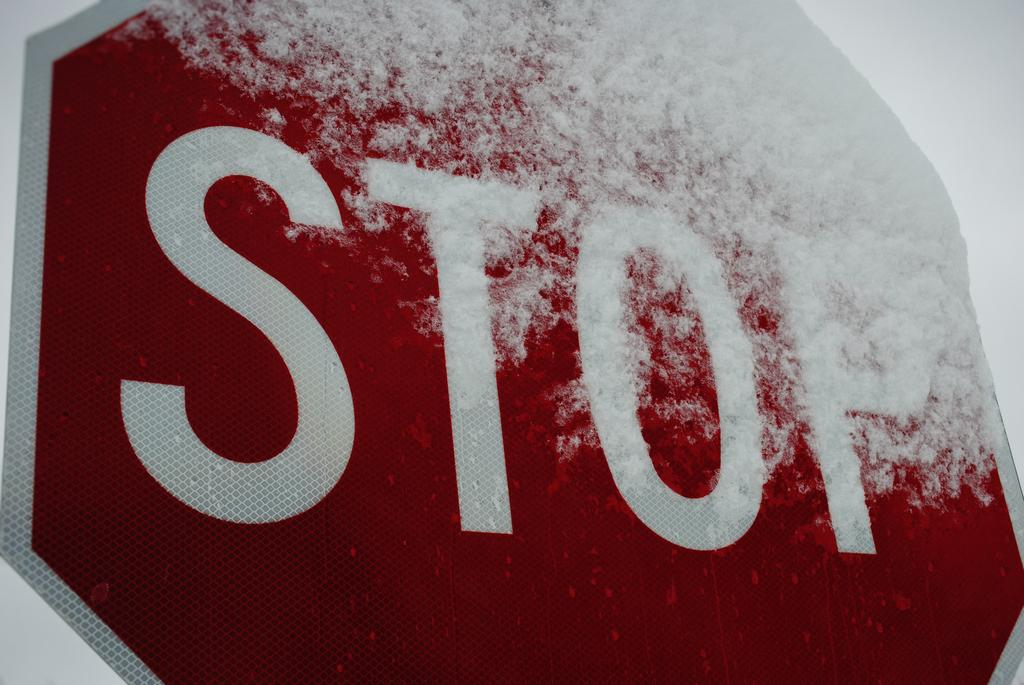<image>
Relay a brief, clear account of the picture shown. A red snow covered STOP sign on a white background 